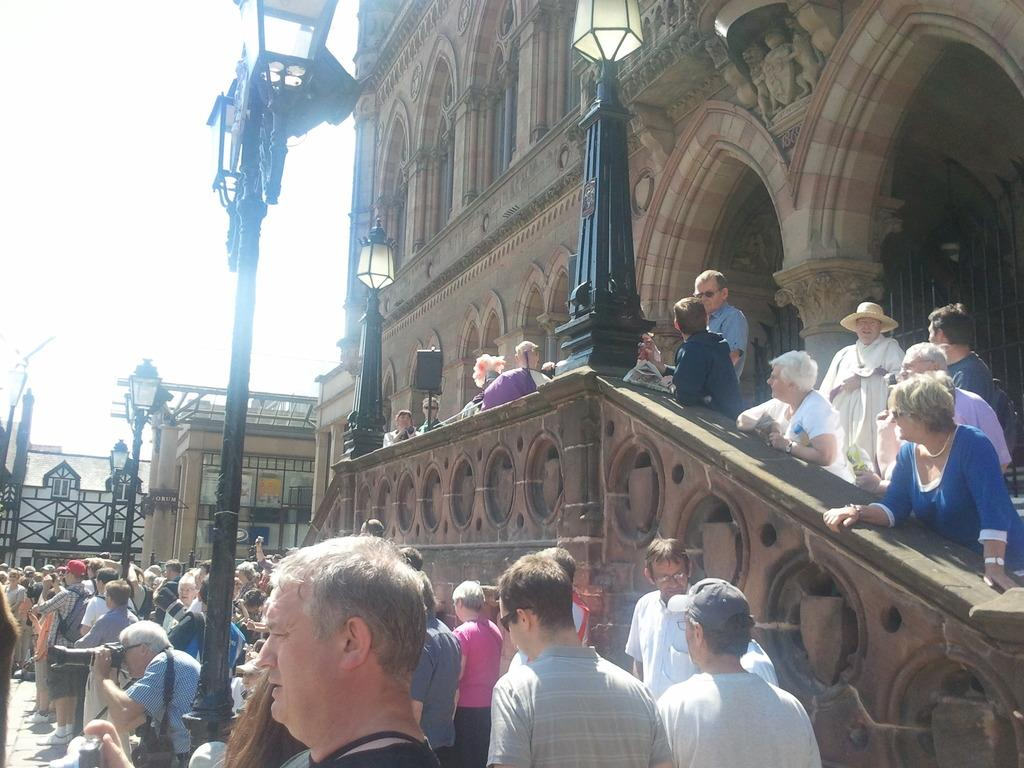What can be seen in the image in terms of people? There are groups of people in the image. What structures are present in the image that are related to lighting? There are poles with lights in the image. What type of structures are located on the right side of the people? There are buildings on the right side of the people. What part of the natural environment is visible in the image? The sky is visible behind the buildings. What type of office can be seen in the image? A: There is no office present in the image; it features groups of people, poles with lights, buildings, and the sky. How many people are kicking a ball in the image? There is no ball or kicking activity present in the image. 